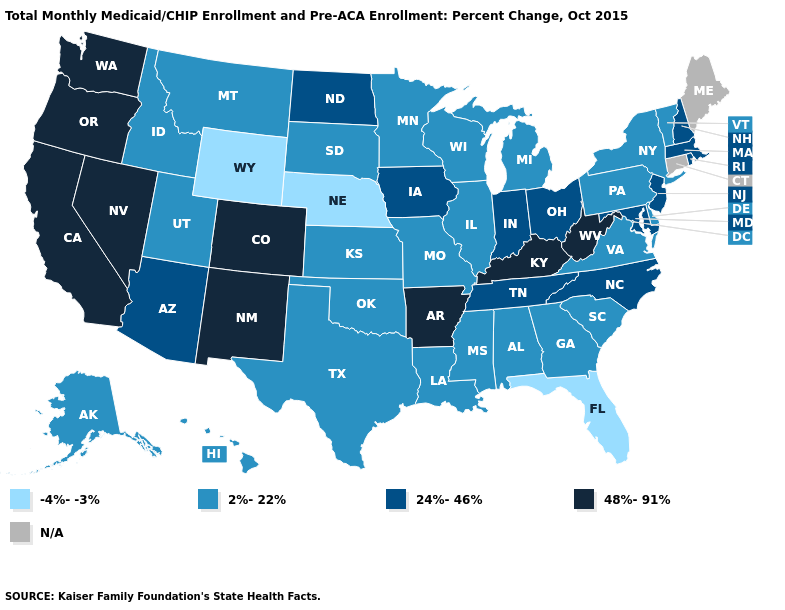Name the states that have a value in the range 2%-22%?
Keep it brief. Alabama, Alaska, Delaware, Georgia, Hawaii, Idaho, Illinois, Kansas, Louisiana, Michigan, Minnesota, Mississippi, Missouri, Montana, New York, Oklahoma, Pennsylvania, South Carolina, South Dakota, Texas, Utah, Vermont, Virginia, Wisconsin. What is the value of Georgia?
Short answer required. 2%-22%. Which states have the highest value in the USA?
Write a very short answer. Arkansas, California, Colorado, Kentucky, Nevada, New Mexico, Oregon, Washington, West Virginia. What is the value of Colorado?
Be succinct. 48%-91%. What is the value of Arizona?
Quick response, please. 24%-46%. Is the legend a continuous bar?
Quick response, please. No. Which states have the lowest value in the USA?
Write a very short answer. Florida, Nebraska, Wyoming. Which states have the lowest value in the Northeast?
Answer briefly. New York, Pennsylvania, Vermont. Among the states that border California , does Arizona have the lowest value?
Keep it brief. Yes. Does Indiana have the highest value in the MidWest?
Short answer required. Yes. What is the lowest value in the USA?
Write a very short answer. -4%--3%. Name the states that have a value in the range 24%-46%?
Be succinct. Arizona, Indiana, Iowa, Maryland, Massachusetts, New Hampshire, New Jersey, North Carolina, North Dakota, Ohio, Rhode Island, Tennessee. Does Florida have the lowest value in the USA?
Be succinct. Yes. 